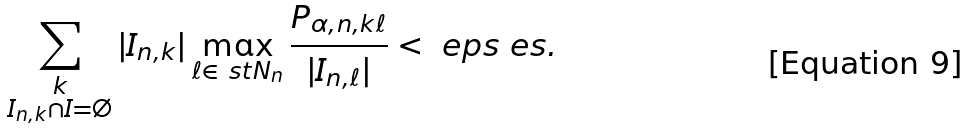Convert formula to latex. <formula><loc_0><loc_0><loc_500><loc_500>\sum _ { \substack { k \\ I _ { n , k } \cap I = \emptyset } } | I _ { n , k } | \max _ { \ell \in \ s t { N } _ { n } } \frac { P _ { \alpha , n , k \ell } } { | I _ { n , \ell } | } < \ e p s \ e s .</formula> 